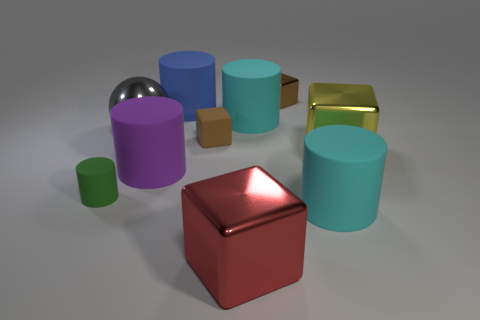Is there any other thing that has the same material as the large purple cylinder?
Your answer should be compact. Yes. What number of other things are there of the same size as the purple object?
Your answer should be compact. 6. There is a large thing in front of the large matte cylinder right of the tiny brown block that is right of the large red metal block; what is its material?
Offer a very short reply. Metal. Is the size of the brown rubber object the same as the cyan rubber cylinder that is in front of the big yellow metallic object?
Offer a very short reply. No. What is the size of the rubber object that is both in front of the brown rubber thing and on the right side of the large blue cylinder?
Your answer should be compact. Large. Are there any tiny cylinders of the same color as the shiny ball?
Make the answer very short. No. What is the color of the rubber thing that is in front of the tiny object that is in front of the yellow metal object?
Your answer should be very brief. Cyan. Is the number of large cyan matte objects that are in front of the large yellow object less than the number of tiny cylinders that are on the left side of the green cylinder?
Provide a succinct answer. No. Do the yellow block and the green cylinder have the same size?
Offer a very short reply. No. There is a matte object that is to the right of the blue rubber object and behind the gray metal ball; what is its shape?
Offer a terse response. Cylinder. 